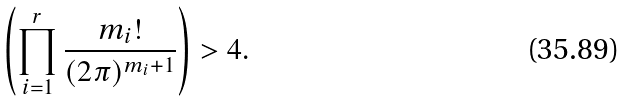Convert formula to latex. <formula><loc_0><loc_0><loc_500><loc_500>\left ( \prod _ { i = 1 } ^ { r } \frac { m _ { i } ! } { ( 2 \pi ) ^ { m _ { i } + 1 } } \right ) > 4 .</formula> 